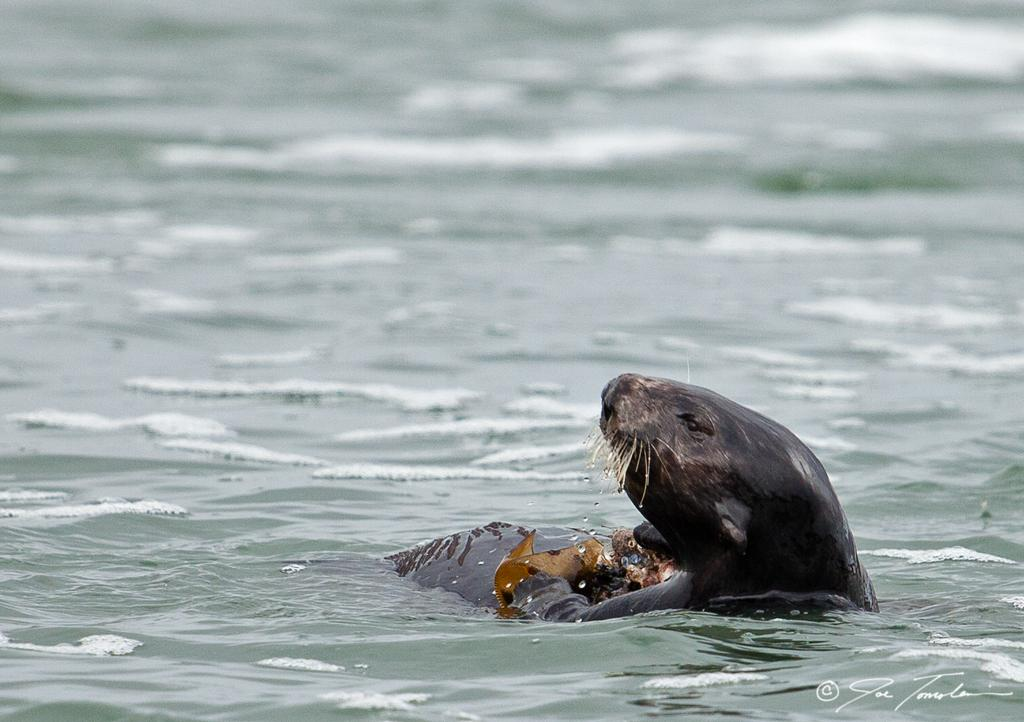What is the animal doing in the image? The animal is in the water in the image. Can you describe any other elements in the image besides the animal? There is a watermark on the image. What type of iron is being used by the grandfather in the image? There is no iron or grandfather present in the image; it only features an animal in the water and a watermark. 